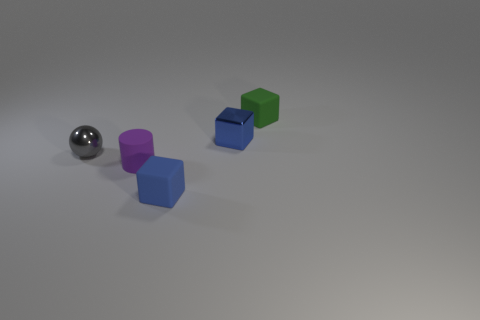Is there anything else that is the same shape as the purple thing?
Your answer should be compact. No. What is the shape of the tiny metallic thing that is on the right side of the blue matte object?
Ensure brevity in your answer.  Cube. There is a blue object right of the blue block that is in front of the thing that is on the left side of the matte cylinder; what is its size?
Ensure brevity in your answer.  Small. There is a small purple cylinder that is in front of the blue shiny object; how many tiny blue rubber blocks are behind it?
Provide a short and direct response. 0. What size is the object that is both to the left of the blue rubber object and right of the tiny metal sphere?
Your answer should be very brief. Small. What number of matte things are tiny green blocks or blue things?
Make the answer very short. 2. What is the small cylinder made of?
Ensure brevity in your answer.  Rubber. What is the green cube that is to the right of the matte cube that is on the left side of the tiny matte block that is behind the tiny blue metallic cube made of?
Provide a succinct answer. Rubber. What shape is the blue matte object that is the same size as the gray thing?
Your answer should be very brief. Cube. What number of things are either cyan objects or small matte objects that are in front of the small ball?
Make the answer very short. 2. 